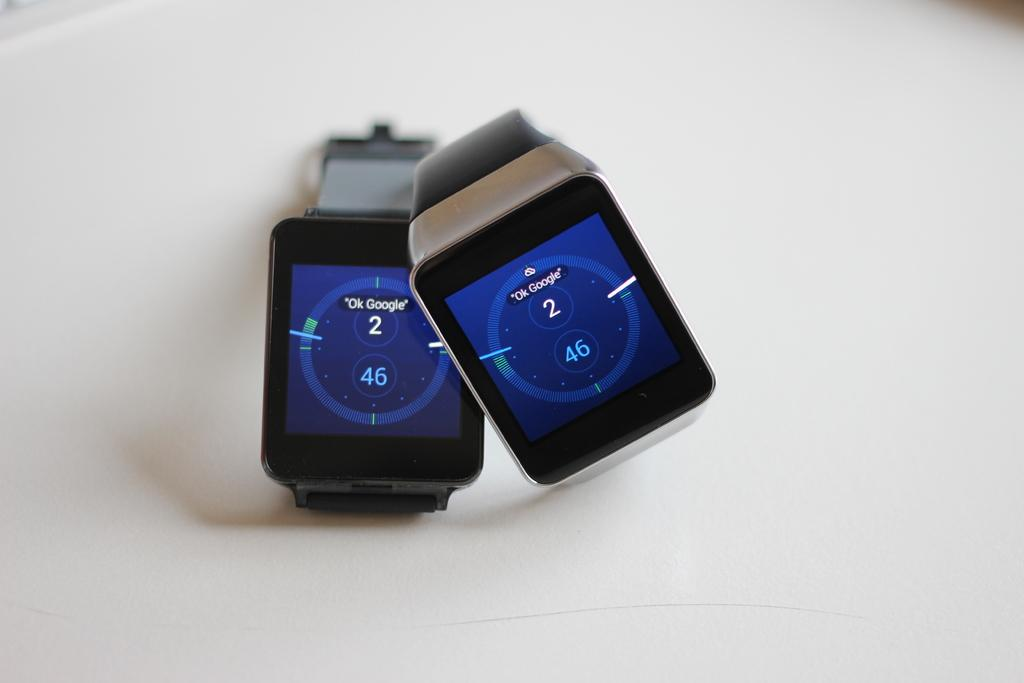How many watches can be seen in the image? There are two watches in the image. What colors are the dials of the watches? The dials of the watches are in blue and black colors. What is present on the dials of the watches? There are numbers on the dials of the watches. What is the color of the background in the image? The background of the image is white. Can you hear the bells ringing in the image? There are no bells present in the image, so it is not possible to hear them ringing. 